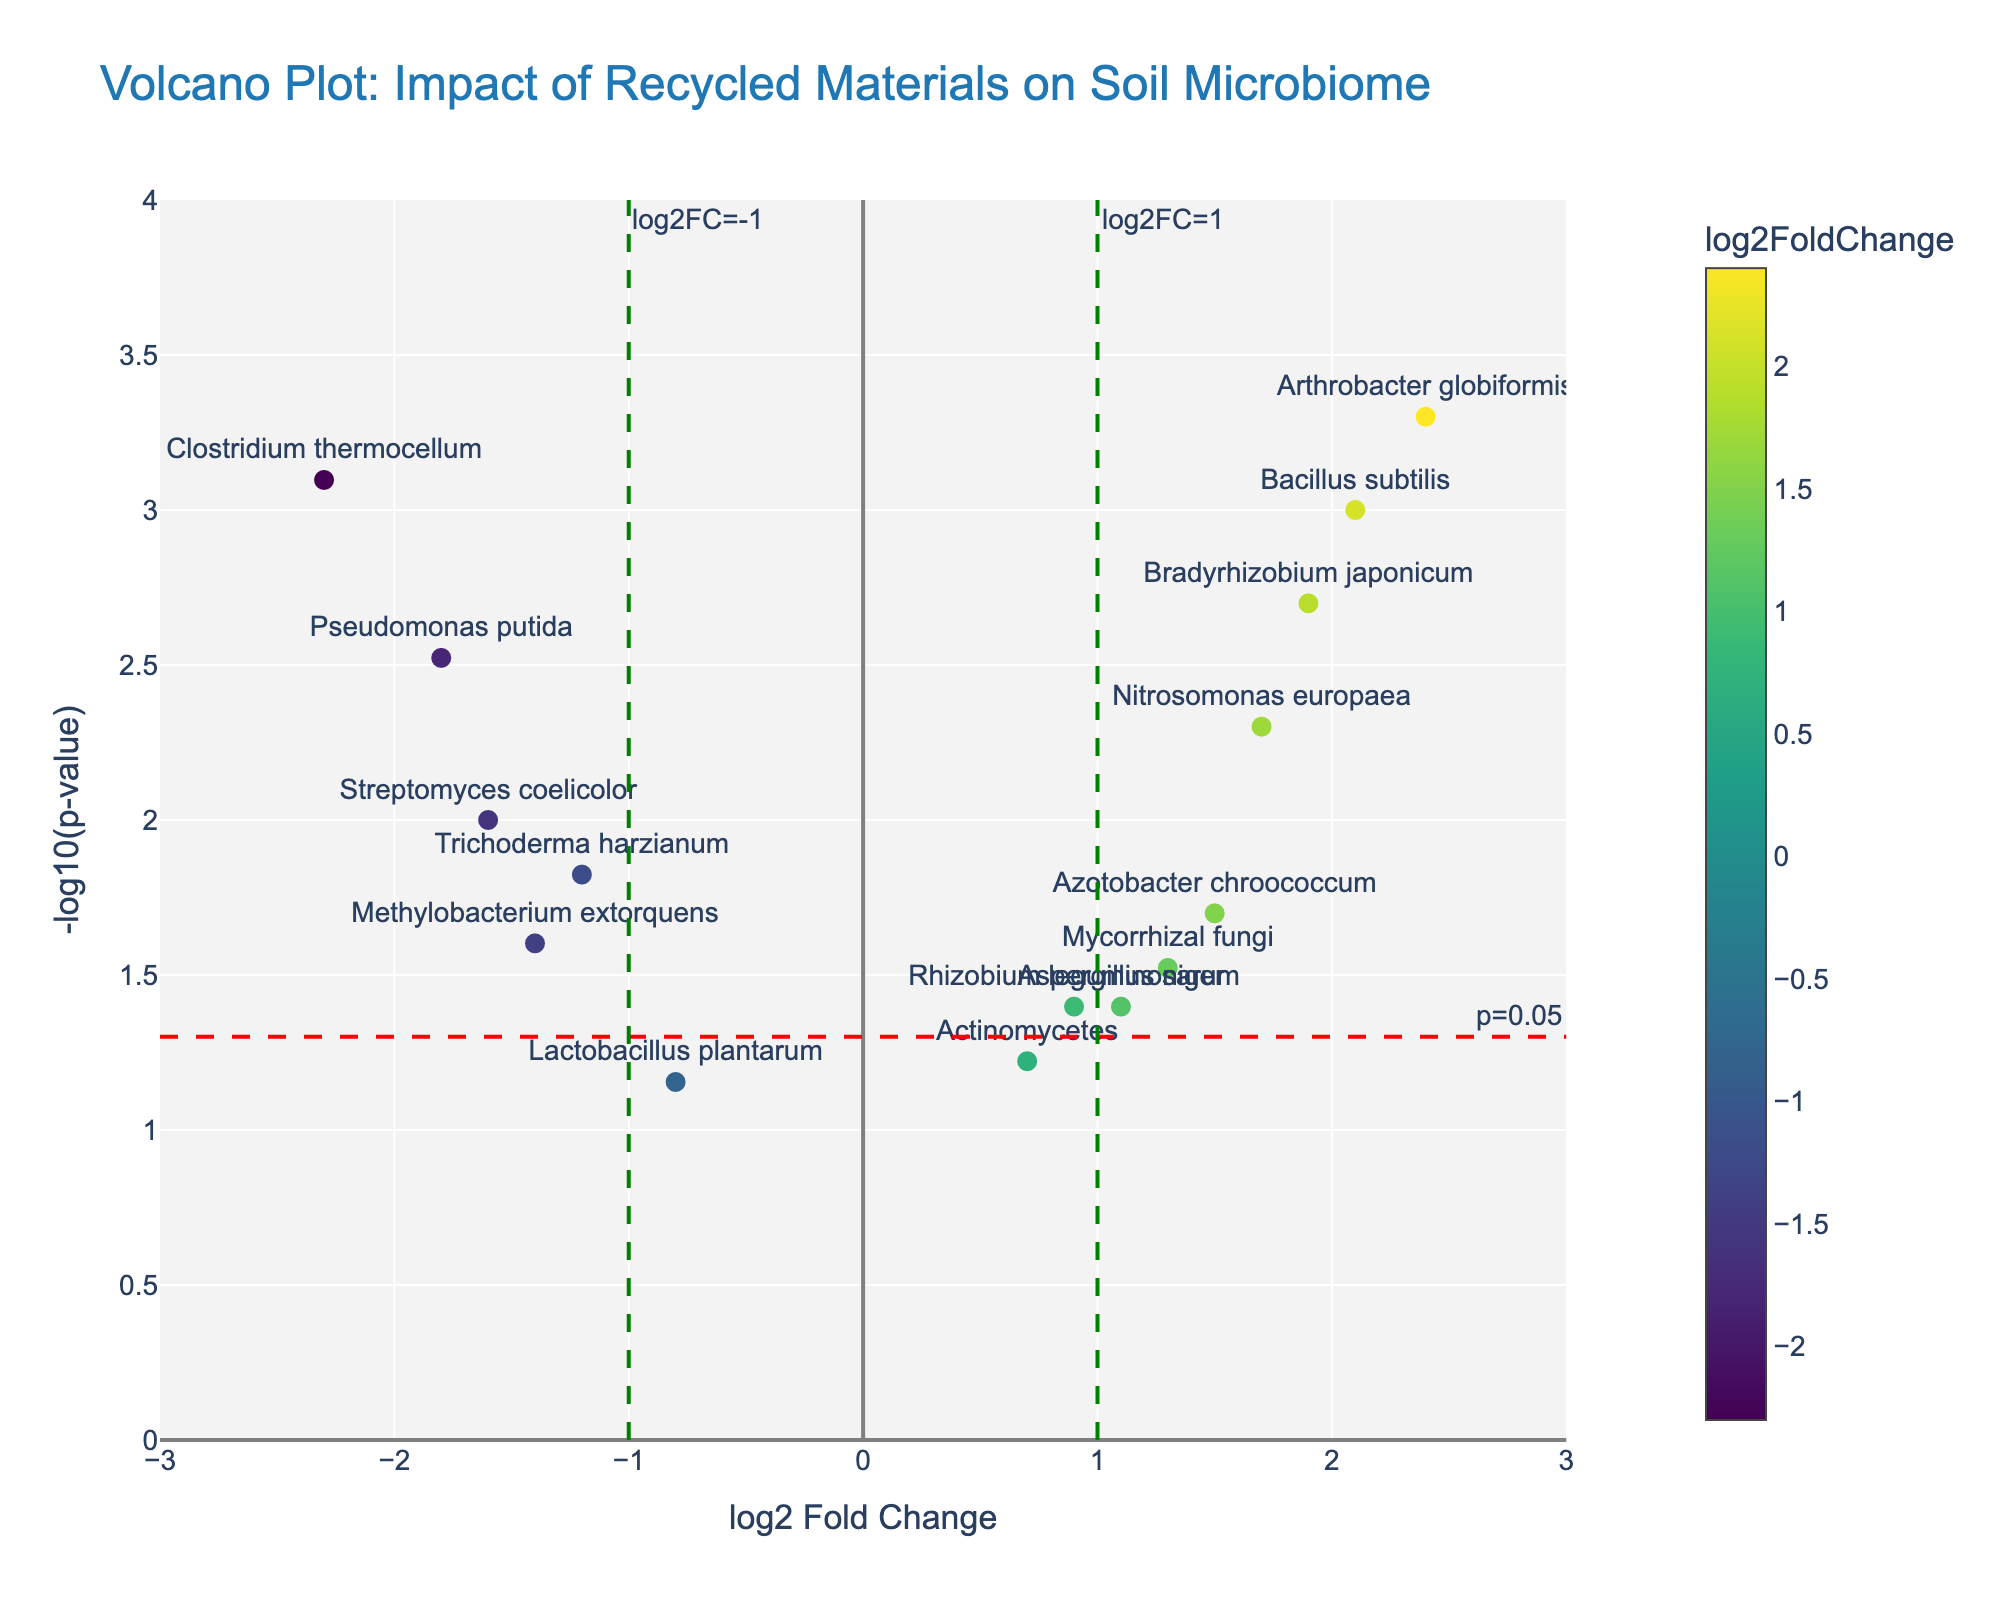How many data points are shown in the Volcano Plot? Count the number of markers representing different genes on the plot. Each marker corresponds to a data point, and there are 15 markers in total.
Answer: 15 What's the title of the plot? Look at the title text displayed at the top of the plot. It reads "Volcano Plot: Impact of Recycled Materials on Soil Microbiome".
Answer: "Volcano Plot: Impact of Recycled Materials on Soil Microbiome" Which gene has the highest log2 fold change? Find the marker situated farthest to the right on the x-axis. The gene labeled closest to that marker is "Arthrobacter globiformis" with a log2 fold change of 2.4.
Answer: "Arthrobacter globiformis" Which genes are statistically significant based on the p-value threshold line at 0.05? Identify markers above the horizontal red dashed line at y=-log10(0.05), indicating a p-value of 0.05. The genes are Bacillus subtilis, Pseudomonas putida, Nitrosomonas europaea, Clostridium thermocellum, Bradyrhizobium japonicum, and Arthrobacter globiformis.
Answer: Bacillus subtilis, Pseudomonas putida, Nitrosomonas europaea, Clostridium thermocellum, Bradyrhizobium japonicum, Arthrobacter globiformis Which genes have a log2 fold change greater than 1 and are statistically significant? Look for markers to the right of the vertical green dashed line at x=1 and above the horizontal red dashed line at y=-log10(0.05). The genes that meet these criteria are Bacillus subtilis, Nitrosomonas europaea, Bradyrhizobium japonicum, and Arthrobacter globiformis.
Answer: Bacillus subtilis, Nitrosomonas europaea, Bradyrhizobium japonicum, Arthrobacter globiformis Which gene has the lowest p-value? Find the marker closest to the top of the plot on the y-axis, representing the highest -log10(p-value). The gene closest to that point is Arthrobacter globiformis with a p-value of 0.0005.
Answer: Arthrobacter globiformis What is the log2 fold change and p-value of Streptomyces coelicolor? Hover over the marker representing Streptomyces coelicolor to view the hovertext. It indicates a log2 fold change of -1.6 and a p-value of 0.01.
Answer: log2 fold change: -1.6, p-value: 0.01 Which genes have a negative log2 fold change and are statistically significant? Locate markers to the left of the vertical green dashed line at x=-1 and above the horizontal red dashed line at y=-log10(0.05). The genes that satisfy these conditions are Pseudomonas putida and Clostridium thermocellum.
Answer: Pseudomonas putida, Clostridium thermocellum 